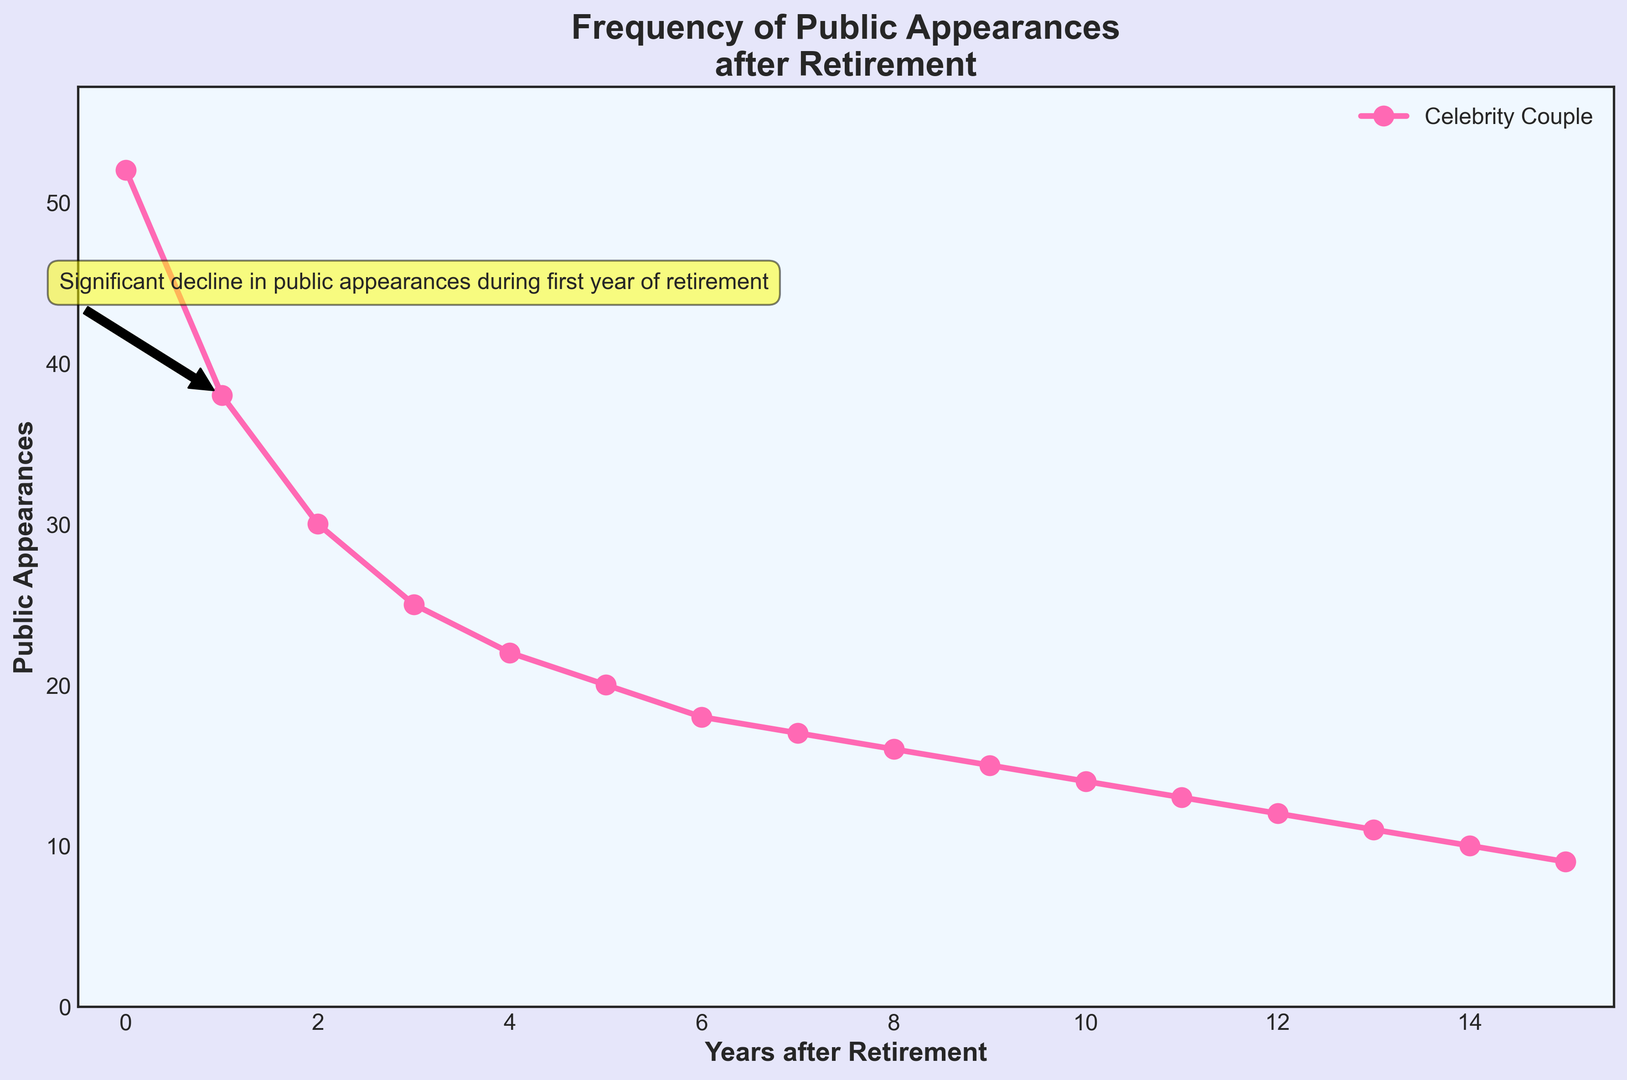What year had the highest number of public appearances? The highest point on the plot is at Year 0, with 52 public appearances.
Answer: Year 0 By how much did the appearances decline from Year 0 to Year 1? The appearances declined from 52 in Year 0 to 38 in Year 1. So, the decline is 52 - 38 = 14.
Answer: 14 What is the average number of public appearances in the first three years after retirement? Sum the appearances for Years 0, 1, and 2, which are 52, 38, and 30. The average is (52 + 38 + 30) / 3 = 120 / 3 = 40.
Answer: 40 In which years did the number of appearances decrease by exactly 2 from the previous year? The appearances decreased by 2 between Years 5 and 6 (20 to 18) and between Years 7 and 8 (17 to 16).
Answer: Years 5 to 6 and Years 7 to 8 What visual attribute indicates the annotation on the figure? The annotation is marked with a yellow box and a black arrow pointing from Year 1 to a text above it.
Answer: Yellow box and black arrow Compare the decline in public appearances between the first and the second half of the data. Which half has a greater average decline per year? First, calculate the average decline for each half. For the first half (Years 0-7): (52 - 17) / 7 = 35 / 7 = 5. For the second half (Years 8-15): (16 - 9) / 7 = 7 / 7 = 1. The first half has a greater average decline.
Answer: First half Which year experienced the greatest reduction in public appearances compared to the previous year? The year with the greatest reduction compared to the previous year is Year 1, with a decline from 52 to 38, a decrease of 14 appearances.
Answer: Year 1 What is the total number of public appearances over the 16 years? Sum all the public appearances from Years 0 to 15: 52 + 38 + 30 + 25 + 22 + 20 + 18 + 17 + 16 + 15 + 14 + 13 + 12 + 11 + 10 + 9 = 312.
Answer: 312 